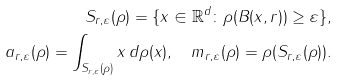Convert formula to latex. <formula><loc_0><loc_0><loc_500><loc_500>S _ { r , \varepsilon } ( \rho ) = \{ x \in \mathbb { R } ^ { d } \colon \rho ( B ( x , r ) ) \geq \varepsilon \} , \\ a _ { r , \varepsilon } ( \rho ) = \int _ { S _ { r , \varepsilon } ( \rho ) } x \, d \rho ( x ) , \quad m _ { r , \varepsilon } ( \rho ) = \rho ( S _ { r , \varepsilon } ( \rho ) ) .</formula> 